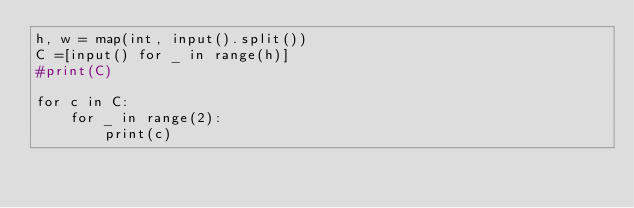Convert code to text. <code><loc_0><loc_0><loc_500><loc_500><_Python_>h, w = map(int, input().split())
C =[input() for _ in range(h)]
#print(C)

for c in C:
    for _ in range(2):
        print(c)</code> 